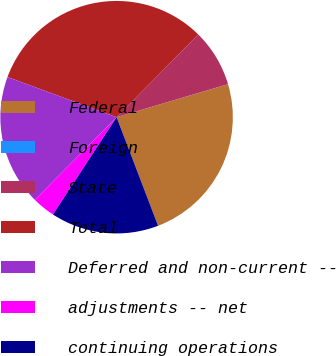<chart> <loc_0><loc_0><loc_500><loc_500><pie_chart><fcel>Federal<fcel>Foreign<fcel>State<fcel>Total<fcel>Deferred and non-current --<fcel>adjustments -- net<fcel>continuing operations<nl><fcel>23.77%<fcel>0.01%<fcel>8.02%<fcel>31.79%<fcel>18.21%<fcel>3.19%<fcel>15.03%<nl></chart> 